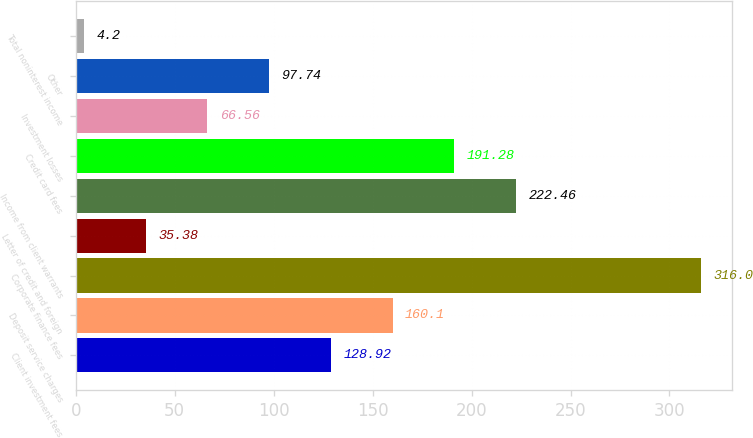Convert chart to OTSL. <chart><loc_0><loc_0><loc_500><loc_500><bar_chart><fcel>Client investment fees<fcel>Deposit service charges<fcel>Corporate finance fees<fcel>Letter of credit and foreign<fcel>Income from client warrants<fcel>Credit card fees<fcel>Investment losses<fcel>Other<fcel>Total noninterest income<nl><fcel>128.92<fcel>160.1<fcel>316<fcel>35.38<fcel>222.46<fcel>191.28<fcel>66.56<fcel>97.74<fcel>4.2<nl></chart> 